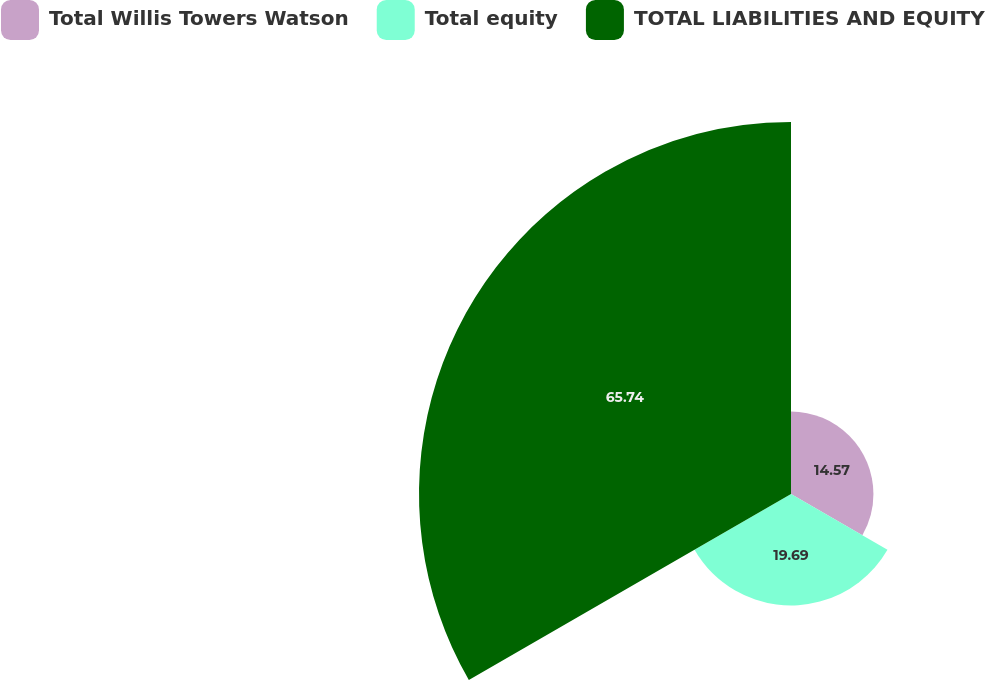Convert chart to OTSL. <chart><loc_0><loc_0><loc_500><loc_500><pie_chart><fcel>Total Willis Towers Watson<fcel>Total equity<fcel>TOTAL LIABILITIES AND EQUITY<nl><fcel>14.57%<fcel>19.69%<fcel>65.75%<nl></chart> 